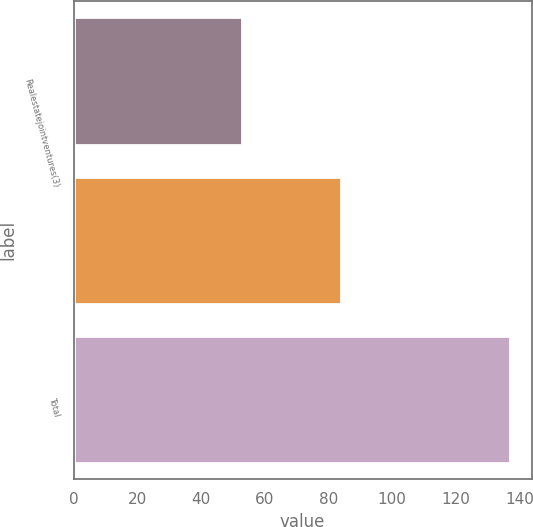Convert chart. <chart><loc_0><loc_0><loc_500><loc_500><bar_chart><fcel>Realestatejointventures(3)<fcel>Unnamed: 1<fcel>Total<nl><fcel>53<fcel>84<fcel>137<nl></chart> 